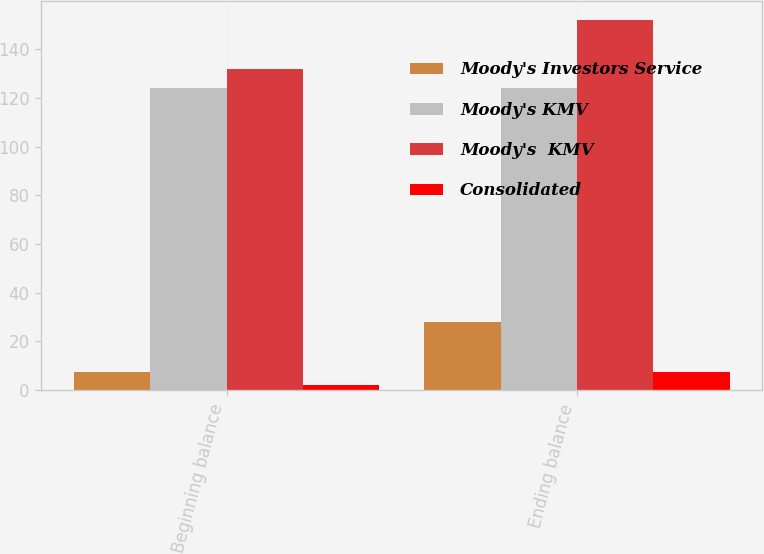Convert chart to OTSL. <chart><loc_0><loc_0><loc_500><loc_500><stacked_bar_chart><ecel><fcel>Beginning balance<fcel>Ending balance<nl><fcel>Moody's Investors Service<fcel>7.6<fcel>28<nl><fcel>Moody's KMV<fcel>124.1<fcel>124.1<nl><fcel>Moody's  KMV<fcel>131.7<fcel>152.1<nl><fcel>Consolidated<fcel>2.3<fcel>7.6<nl></chart> 